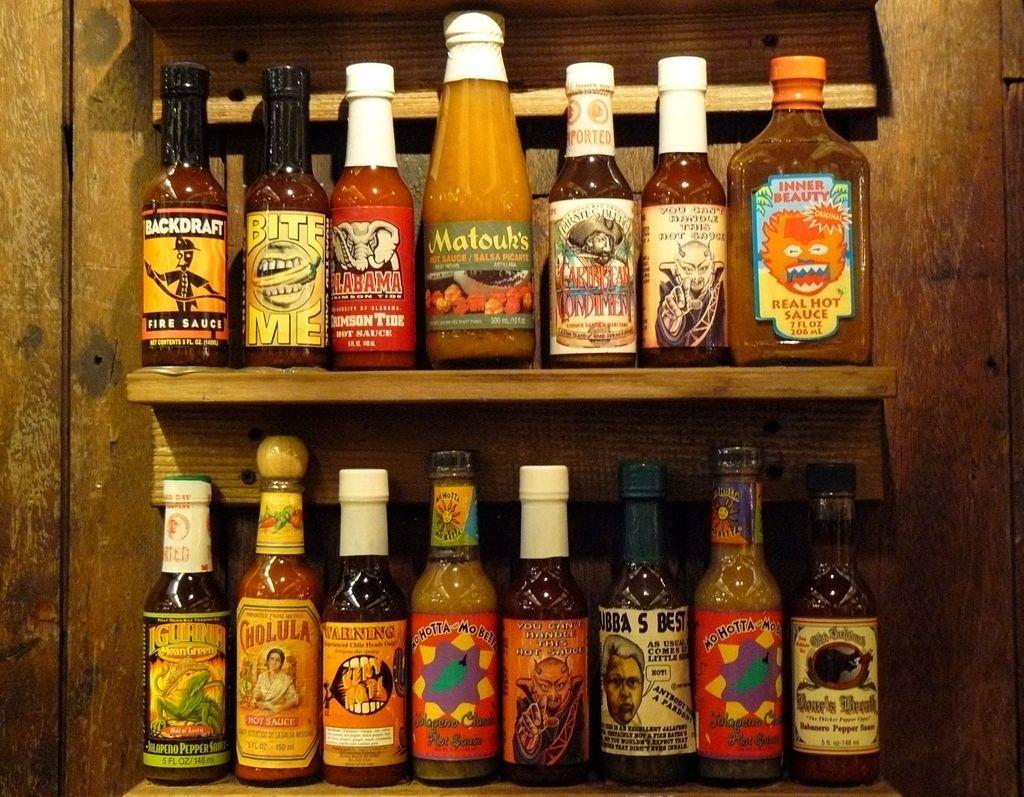Describe this image in one or two sentences. In the image we can see there is a shelf in which there are bottles which are kept in each shelf. 